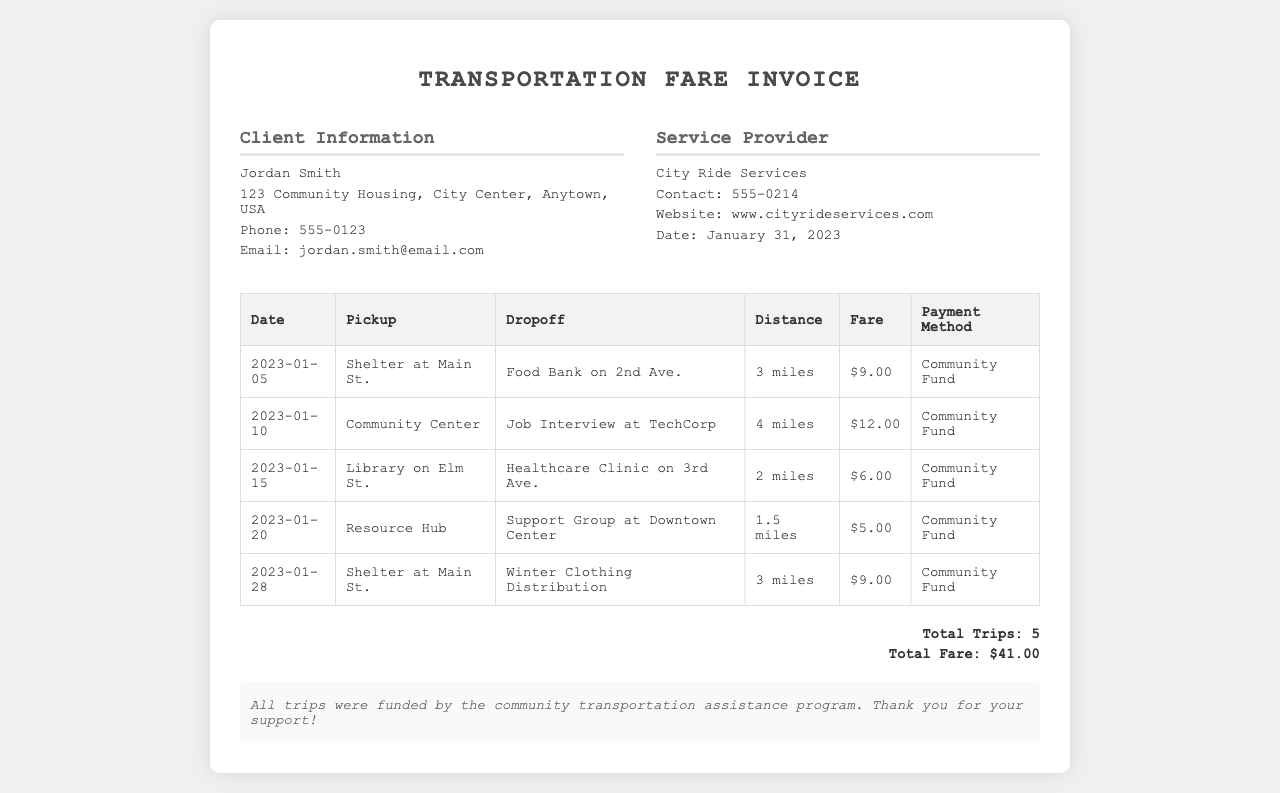What is the total fare? The total fare is the sum of all individual fares listed in the table, which is $9.00 + $12.00 + $6.00 + $5.00 + $9.00 = $41.00.
Answer: $41.00 Who is the service provider? The service provider's name is listed in the document under the provider information section.
Answer: City Ride Services What is the pickup location for the trip on January 20, 2023? The pickup location for that trip is specified in the table for that date.
Answer: Resource Hub How many trips were taken in January 2023? The total number of trips is summarized at the end of the document, which is stated clearly.
Answer: 5 What was the fare for the trip from the Shelter at Main St. to the Food Bank on 2nd Ave.? The fare for that specific trip is indicated in the fare column of the table.
Answer: $9.00 What payment method was used for the trips? The payment method is consistently noted in the table for all trips, only one method is mentioned.
Answer: Community Fund What date was the invoice issued? The specific date when the invoice was issued is mentioned near the provider information.
Answer: January 31, 2023 What is the purpose of the community transportation assistance program? The purpose is inferred from the notes section of the document, indicating funding details.
Answer: To assist with transportation costs 